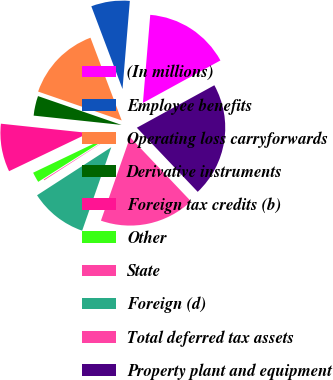Convert chart. <chart><loc_0><loc_0><loc_500><loc_500><pie_chart><fcel>(In millions)<fcel>Employee benefits<fcel>Operating loss carryforwards<fcel>Derivative instruments<fcel>Foreign tax credits (b)<fcel>Other<fcel>State<fcel>Foreign (d)<fcel>Total deferred tax assets<fcel>Property plant and equipment<nl><fcel>15.7%<fcel>7.06%<fcel>13.97%<fcel>3.61%<fcel>8.79%<fcel>1.88%<fcel>0.15%<fcel>10.52%<fcel>17.43%<fcel>20.89%<nl></chart> 